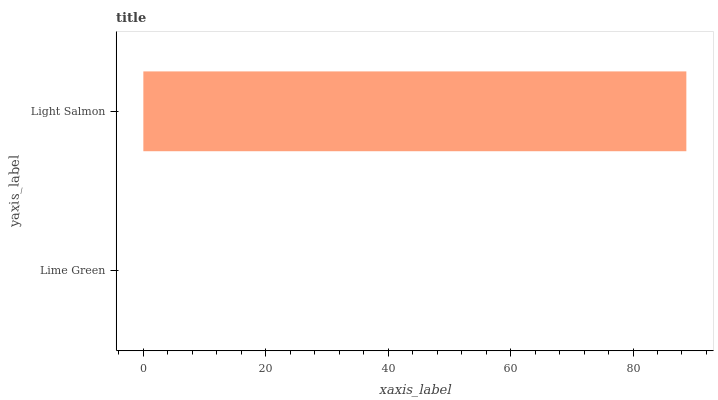Is Lime Green the minimum?
Answer yes or no. Yes. Is Light Salmon the maximum?
Answer yes or no. Yes. Is Light Salmon the minimum?
Answer yes or no. No. Is Light Salmon greater than Lime Green?
Answer yes or no. Yes. Is Lime Green less than Light Salmon?
Answer yes or no. Yes. Is Lime Green greater than Light Salmon?
Answer yes or no. No. Is Light Salmon less than Lime Green?
Answer yes or no. No. Is Light Salmon the high median?
Answer yes or no. Yes. Is Lime Green the low median?
Answer yes or no. Yes. Is Lime Green the high median?
Answer yes or no. No. Is Light Salmon the low median?
Answer yes or no. No. 